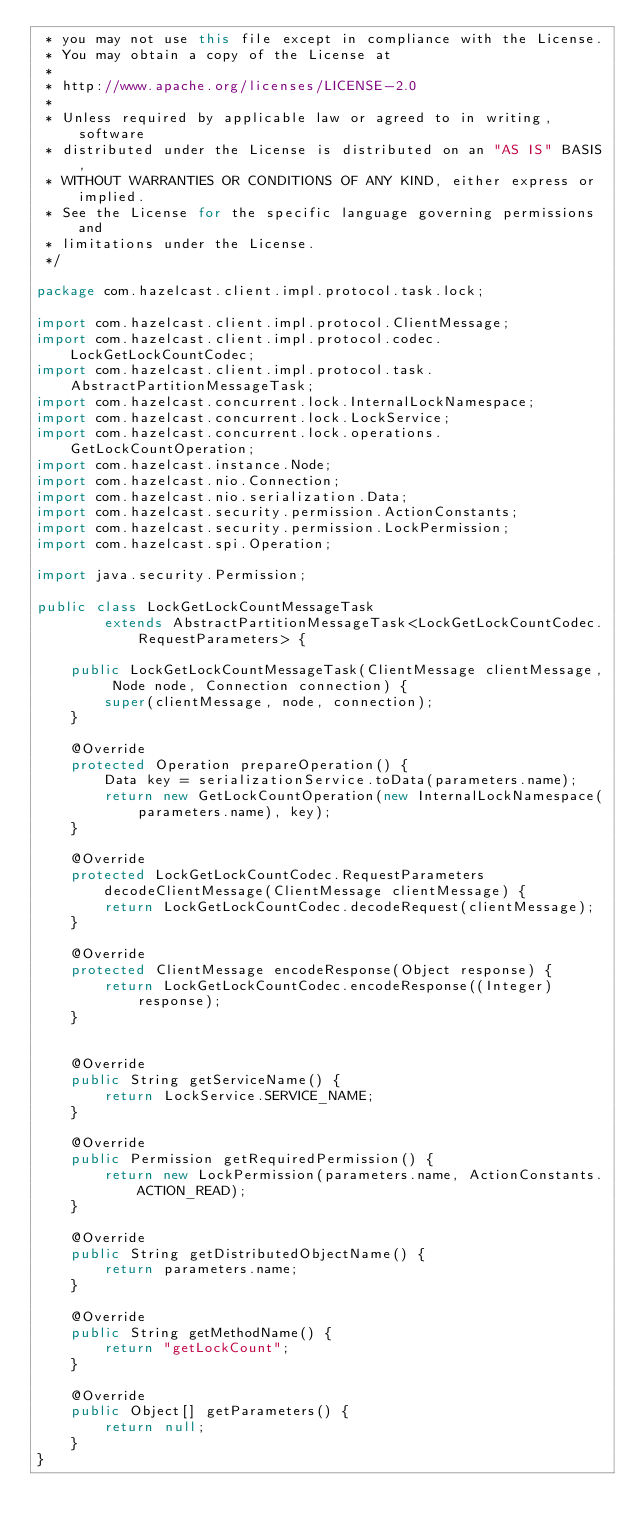<code> <loc_0><loc_0><loc_500><loc_500><_Java_> * you may not use this file except in compliance with the License.
 * You may obtain a copy of the License at
 *
 * http://www.apache.org/licenses/LICENSE-2.0
 *
 * Unless required by applicable law or agreed to in writing, software
 * distributed under the License is distributed on an "AS IS" BASIS,
 * WITHOUT WARRANTIES OR CONDITIONS OF ANY KIND, either express or implied.
 * See the License for the specific language governing permissions and
 * limitations under the License.
 */

package com.hazelcast.client.impl.protocol.task.lock;

import com.hazelcast.client.impl.protocol.ClientMessage;
import com.hazelcast.client.impl.protocol.codec.LockGetLockCountCodec;
import com.hazelcast.client.impl.protocol.task.AbstractPartitionMessageTask;
import com.hazelcast.concurrent.lock.InternalLockNamespace;
import com.hazelcast.concurrent.lock.LockService;
import com.hazelcast.concurrent.lock.operations.GetLockCountOperation;
import com.hazelcast.instance.Node;
import com.hazelcast.nio.Connection;
import com.hazelcast.nio.serialization.Data;
import com.hazelcast.security.permission.ActionConstants;
import com.hazelcast.security.permission.LockPermission;
import com.hazelcast.spi.Operation;

import java.security.Permission;

public class LockGetLockCountMessageTask
        extends AbstractPartitionMessageTask<LockGetLockCountCodec.RequestParameters> {

    public LockGetLockCountMessageTask(ClientMessage clientMessage, Node node, Connection connection) {
        super(clientMessage, node, connection);
    }

    @Override
    protected Operation prepareOperation() {
        Data key = serializationService.toData(parameters.name);
        return new GetLockCountOperation(new InternalLockNamespace(parameters.name), key);
    }

    @Override
    protected LockGetLockCountCodec.RequestParameters decodeClientMessage(ClientMessage clientMessage) {
        return LockGetLockCountCodec.decodeRequest(clientMessage);
    }

    @Override
    protected ClientMessage encodeResponse(Object response) {
        return LockGetLockCountCodec.encodeResponse((Integer) response);
    }


    @Override
    public String getServiceName() {
        return LockService.SERVICE_NAME;
    }

    @Override
    public Permission getRequiredPermission() {
        return new LockPermission(parameters.name, ActionConstants.ACTION_READ);
    }

    @Override
    public String getDistributedObjectName() {
        return parameters.name;
    }

    @Override
    public String getMethodName() {
        return "getLockCount";
    }

    @Override
    public Object[] getParameters() {
        return null;
    }
}
</code> 